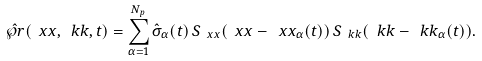<formula> <loc_0><loc_0><loc_500><loc_500>\hat { \wp r } ( \ x x , \ k k , t ) = \sum _ { \alpha = 1 } ^ { N _ { p } } \hat { \sigma } _ { \alpha } ( t ) \, S _ { \ x x } ( \ x x - \ x x _ { \alpha } ( t ) ) \, S _ { \ k k } ( \ k k - \ k k _ { \alpha } ( t ) ) .</formula> 